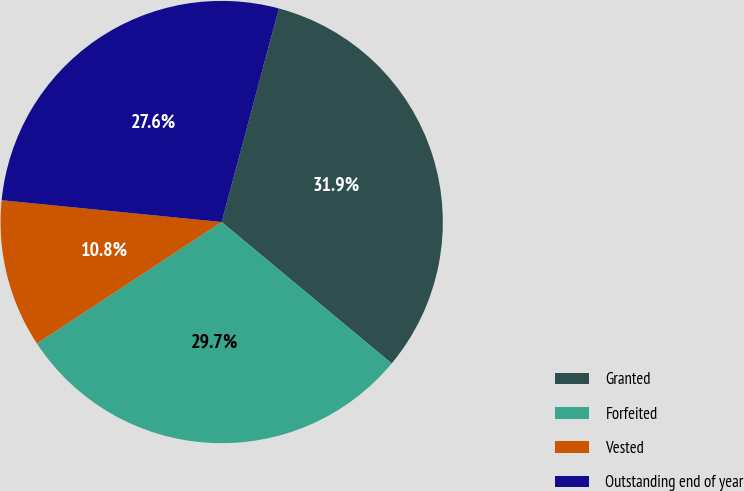Convert chart to OTSL. <chart><loc_0><loc_0><loc_500><loc_500><pie_chart><fcel>Granted<fcel>Forfeited<fcel>Vested<fcel>Outstanding end of year<nl><fcel>31.88%<fcel>29.7%<fcel>10.83%<fcel>27.59%<nl></chart> 